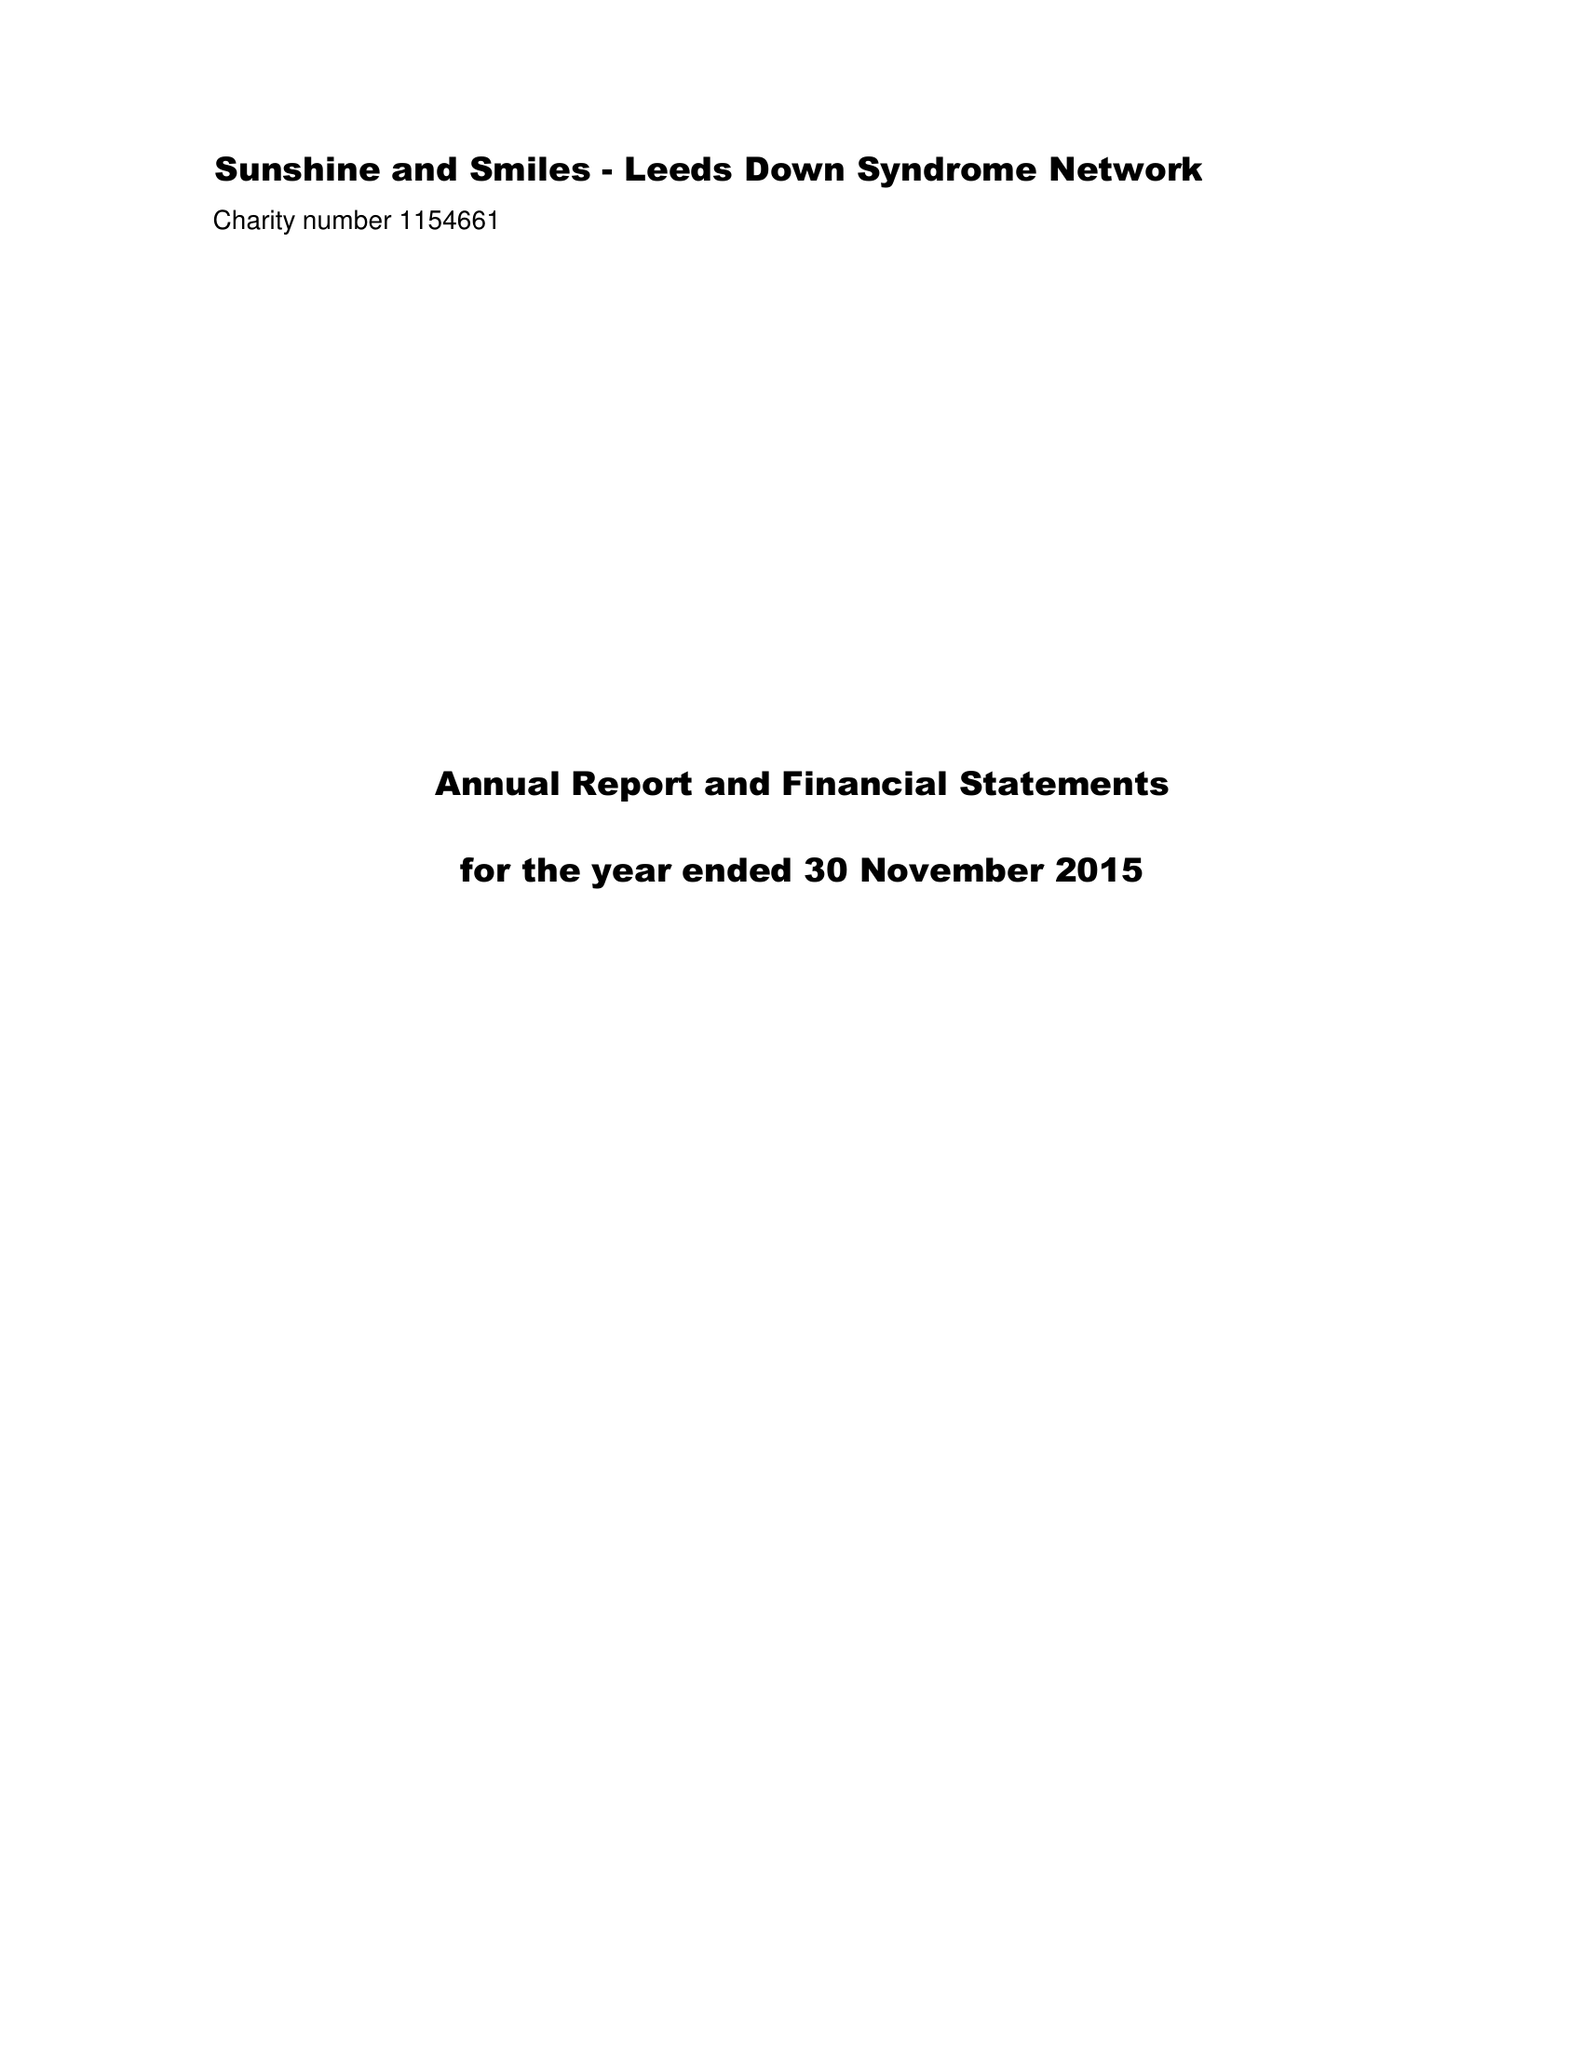What is the value for the charity_name?
Answer the question using a single word or phrase. Sunshine and Smiles - Leeds Down Syndrome Network 